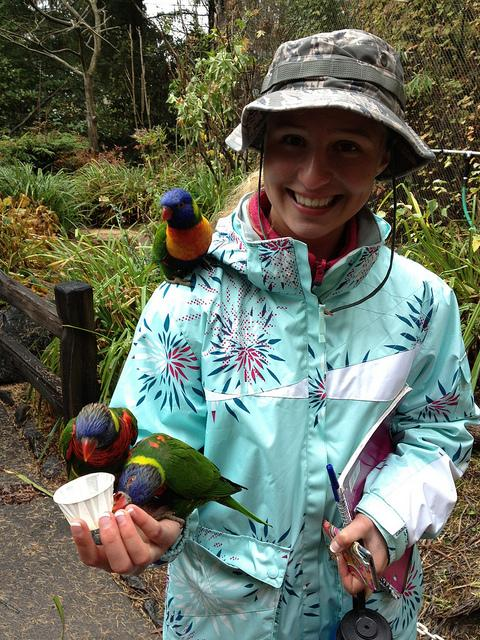What color is the rain jacket worn by the woman in the rainforest? blue 